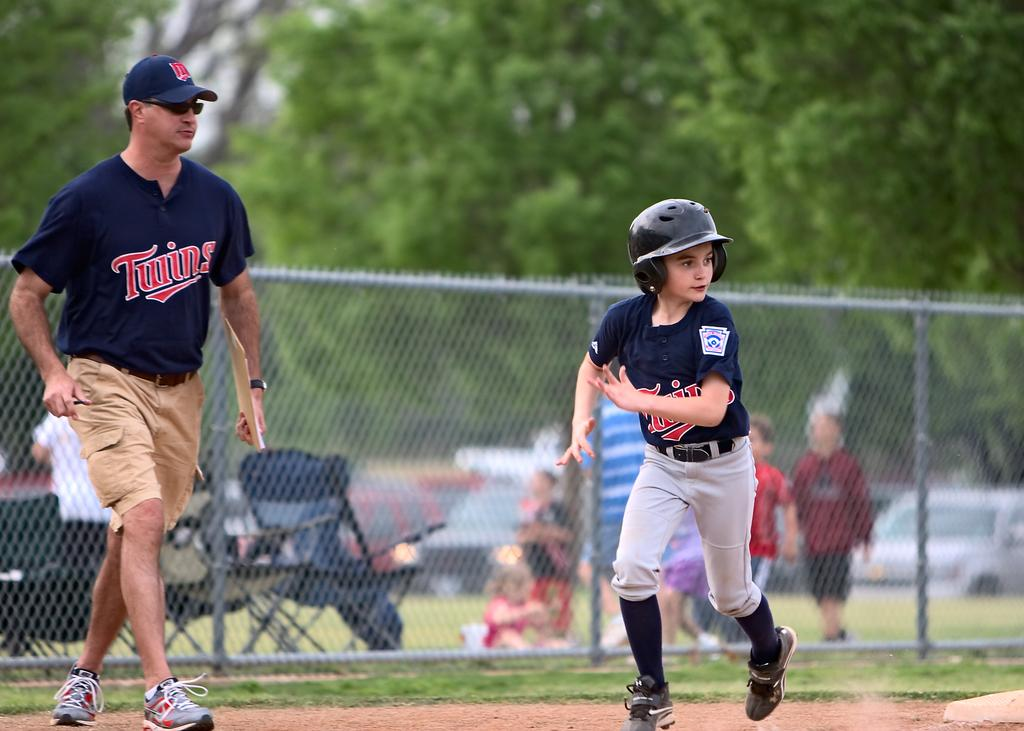<image>
Relay a brief, clear account of the picture shown. A boy running bases while a man in a Twins shirt looks on. 